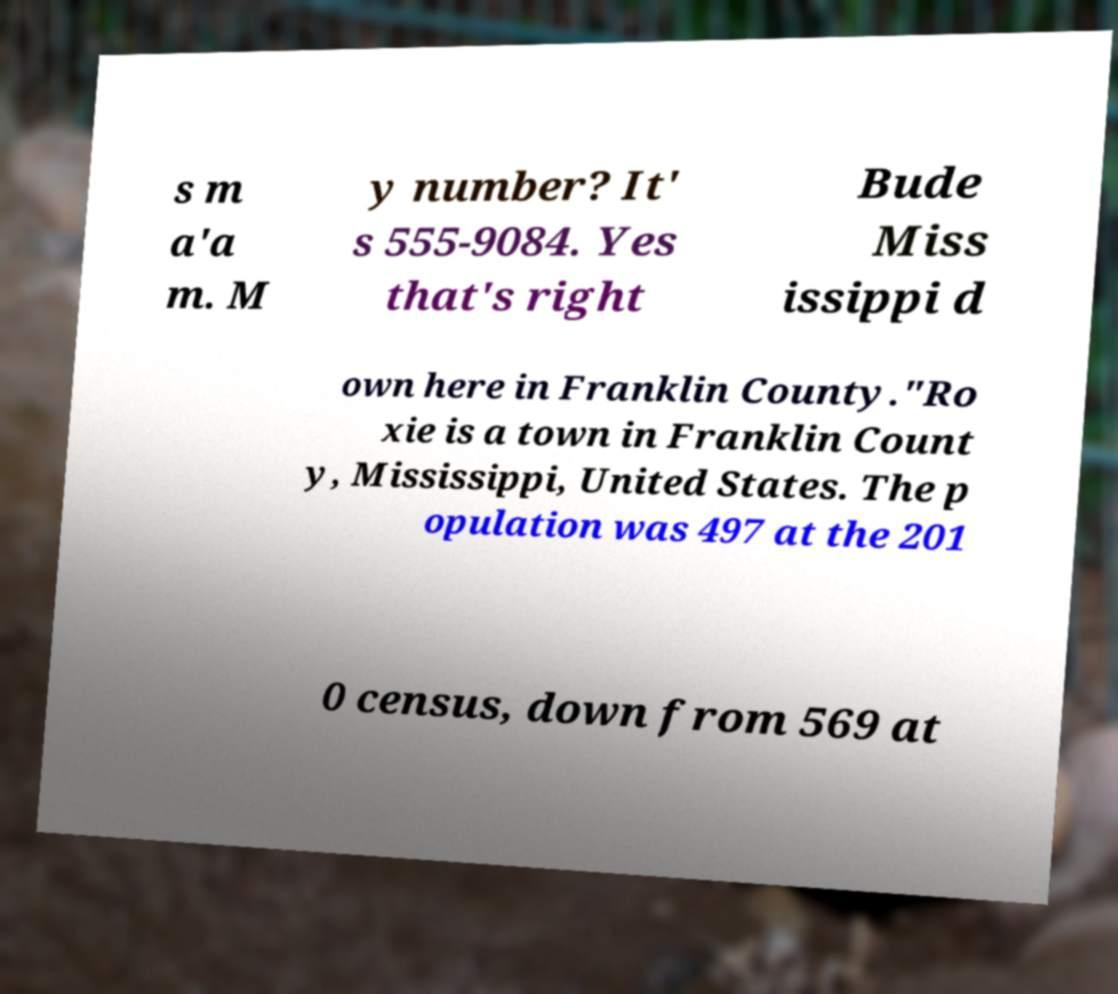Could you extract and type out the text from this image? s m a'a m. M y number? It' s 555-9084. Yes that's right Bude Miss issippi d own here in Franklin County."Ro xie is a town in Franklin Count y, Mississippi, United States. The p opulation was 497 at the 201 0 census, down from 569 at 